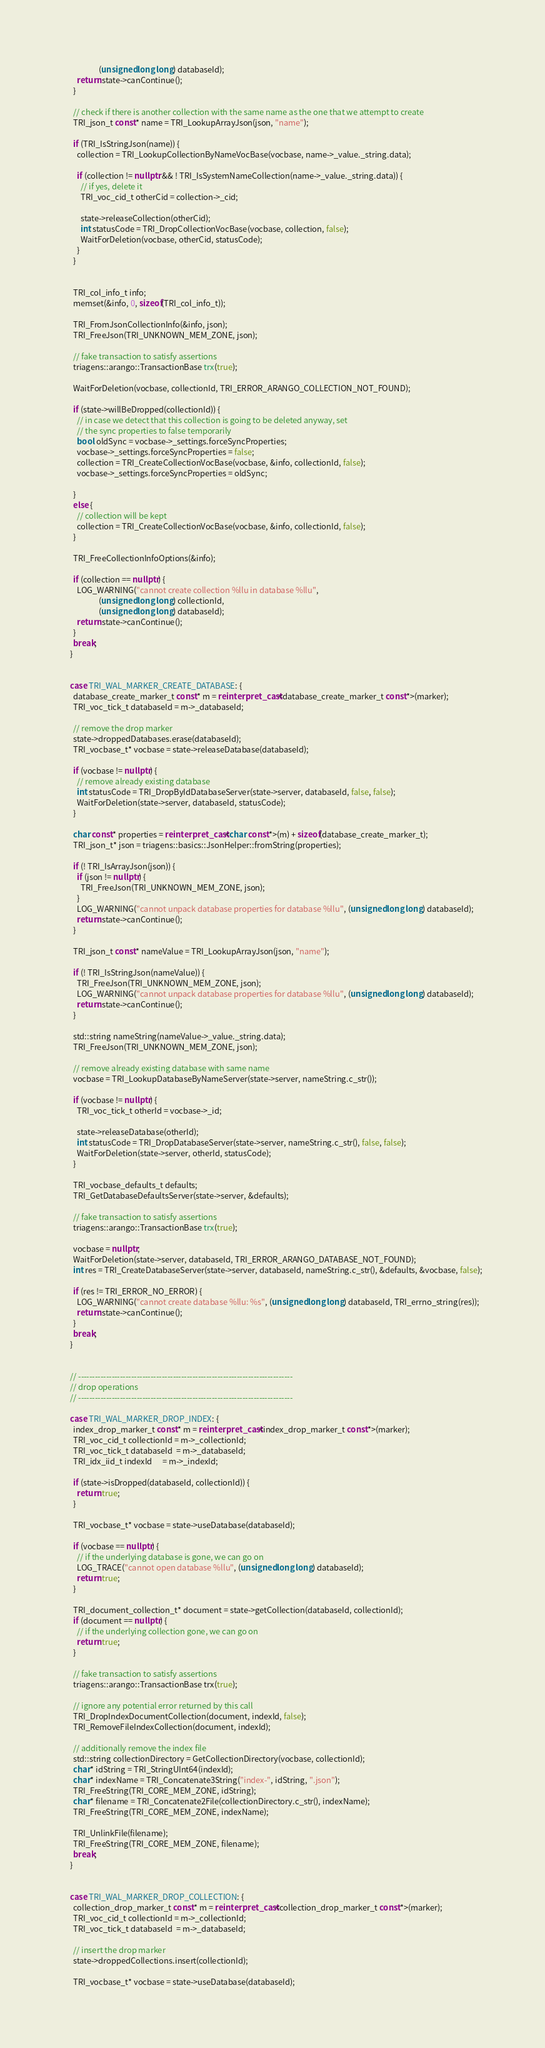<code> <loc_0><loc_0><loc_500><loc_500><_C++_>                    (unsigned long long) databaseId);
        return state->canContinue();
      }

      // check if there is another collection with the same name as the one that we attempt to create
      TRI_json_t const* name = TRI_LookupArrayJson(json, "name");

      if (TRI_IsStringJson(name)) {
        collection = TRI_LookupCollectionByNameVocBase(vocbase, name->_value._string.data);
        
        if (collection != nullptr && ! TRI_IsSystemNameCollection(name->_value._string.data)) {
          // if yes, delete it
          TRI_voc_cid_t otherCid = collection->_cid;

          state->releaseCollection(otherCid);
          int statusCode = TRI_DropCollectionVocBase(vocbase, collection, false);
          WaitForDeletion(vocbase, otherCid, statusCode);
        }
      }

      
      TRI_col_info_t info;
      memset(&info, 0, sizeof(TRI_col_info_t));

      TRI_FromJsonCollectionInfo(&info, json);
      TRI_FreeJson(TRI_UNKNOWN_MEM_ZONE, json);
      
      // fake transaction to satisfy assertions
      triagens::arango::TransactionBase trx(true); 

      WaitForDeletion(vocbase, collectionId, TRI_ERROR_ARANGO_COLLECTION_NOT_FOUND);
  
      if (state->willBeDropped(collectionId)) {
        // in case we detect that this collection is going to be deleted anyway, set
        // the sync properties to false temporarily
        bool oldSync = vocbase->_settings.forceSyncProperties;
        vocbase->_settings.forceSyncProperties = false;
        collection = TRI_CreateCollectionVocBase(vocbase, &info, collectionId, false);
        vocbase->_settings.forceSyncProperties = oldSync;

      }
      else {
        // collection will be kept
        collection = TRI_CreateCollectionVocBase(vocbase, &info, collectionId, false);
      }

      TRI_FreeCollectionInfoOptions(&info);

      if (collection == nullptr) {
        LOG_WARNING("cannot create collection %llu in database %llu", 
                    (unsigned long long) collectionId, 
                    (unsigned long long) databaseId);
        return state->canContinue();
      }
      break;
    }


    case TRI_WAL_MARKER_CREATE_DATABASE: {
      database_create_marker_t const* m = reinterpret_cast<database_create_marker_t const*>(marker);
      TRI_voc_tick_t databaseId = m->_databaseId;
     
      // remove the drop marker 
      state->droppedDatabases.erase(databaseId);
      TRI_vocbase_t* vocbase = state->releaseDatabase(databaseId);

      if (vocbase != nullptr) {
        // remove already existing database
        int statusCode = TRI_DropByIdDatabaseServer(state->server, databaseId, false, false);
        WaitForDeletion(state->server, databaseId, statusCode);
      }

      char const* properties = reinterpret_cast<char const*>(m) + sizeof(database_create_marker_t);
      TRI_json_t* json = triagens::basics::JsonHelper::fromString(properties);
        
      if (! TRI_IsArrayJson(json)) {
        if (json != nullptr) {
          TRI_FreeJson(TRI_UNKNOWN_MEM_ZONE, json);
        }
        LOG_WARNING("cannot unpack database properties for database %llu", (unsigned long long) databaseId);
        return state->canContinue();
      }

      TRI_json_t const* nameValue = TRI_LookupArrayJson(json, "name");

      if (! TRI_IsStringJson(nameValue)) {
        TRI_FreeJson(TRI_UNKNOWN_MEM_ZONE, json);
        LOG_WARNING("cannot unpack database properties for database %llu", (unsigned long long) databaseId);
        return state->canContinue();
      }

      std::string nameString(nameValue->_value._string.data);
      TRI_FreeJson(TRI_UNKNOWN_MEM_ZONE, json);

      // remove already existing database with same name
      vocbase = TRI_LookupDatabaseByNameServer(state->server, nameString.c_str());

      if (vocbase != nullptr) {
        TRI_voc_tick_t otherId = vocbase->_id;

        state->releaseDatabase(otherId);
        int statusCode = TRI_DropDatabaseServer(state->server, nameString.c_str(), false, false);
        WaitForDeletion(state->server, otherId, statusCode);
      }

      TRI_vocbase_defaults_t defaults;
      TRI_GetDatabaseDefaultsServer(state->server, &defaults);
      
      // fake transaction to satisfy assertions
      triagens::arango::TransactionBase trx(true); 

      vocbase = nullptr;
      WaitForDeletion(state->server, databaseId, TRI_ERROR_ARANGO_DATABASE_NOT_FOUND);
      int res = TRI_CreateDatabaseServer(state->server, databaseId, nameString.c_str(), &defaults, &vocbase, false);

      if (res != TRI_ERROR_NO_ERROR) {
        LOG_WARNING("cannot create database %llu: %s", (unsigned long long) databaseId, TRI_errno_string(res));
        return state->canContinue();
      }
      break;
    }


    // -----------------------------------------------------------------------------
    // drop operations
    // -----------------------------------------------------------------------------
    
    case TRI_WAL_MARKER_DROP_INDEX: {
      index_drop_marker_t const* m = reinterpret_cast<index_drop_marker_t const*>(marker);
      TRI_voc_cid_t collectionId = m->_collectionId;
      TRI_voc_tick_t databaseId  = m->_databaseId;
      TRI_idx_iid_t indexId      = m->_indexId;

      if (state->isDropped(databaseId, collectionId)) {
        return true;
      }
      
      TRI_vocbase_t* vocbase = state->useDatabase(databaseId);

      if (vocbase == nullptr) {
        // if the underlying database is gone, we can go on
        LOG_TRACE("cannot open database %llu", (unsigned long long) databaseId);
        return true;
      }
            
      TRI_document_collection_t* document = state->getCollection(databaseId, collectionId);
      if (document == nullptr) {
        // if the underlying collection gone, we can go on
        return true;
      }
      
      // fake transaction to satisfy assertions
      triagens::arango::TransactionBase trx(true); 

      // ignore any potential error returned by this call
      TRI_DropIndexDocumentCollection(document, indexId, false);
      TRI_RemoveFileIndexCollection(document, indexId);

      // additionally remove the index file
      std::string collectionDirectory = GetCollectionDirectory(vocbase, collectionId);
      char* idString = TRI_StringUInt64(indexId);
      char* indexName = TRI_Concatenate3String("index-", idString, ".json");
      TRI_FreeString(TRI_CORE_MEM_ZONE, idString);
      char* filename = TRI_Concatenate2File(collectionDirectory.c_str(), indexName);
      TRI_FreeString(TRI_CORE_MEM_ZONE, indexName);
      
      TRI_UnlinkFile(filename);
      TRI_FreeString(TRI_CORE_MEM_ZONE, filename);
      break;
    }


    case TRI_WAL_MARKER_DROP_COLLECTION: {
      collection_drop_marker_t const* m = reinterpret_cast<collection_drop_marker_t const*>(marker);
      TRI_voc_cid_t collectionId = m->_collectionId;
      TRI_voc_tick_t databaseId  = m->_databaseId;
      
      // insert the drop marker 
      state->droppedCollections.insert(collectionId);

      TRI_vocbase_t* vocbase = state->useDatabase(databaseId);</code> 